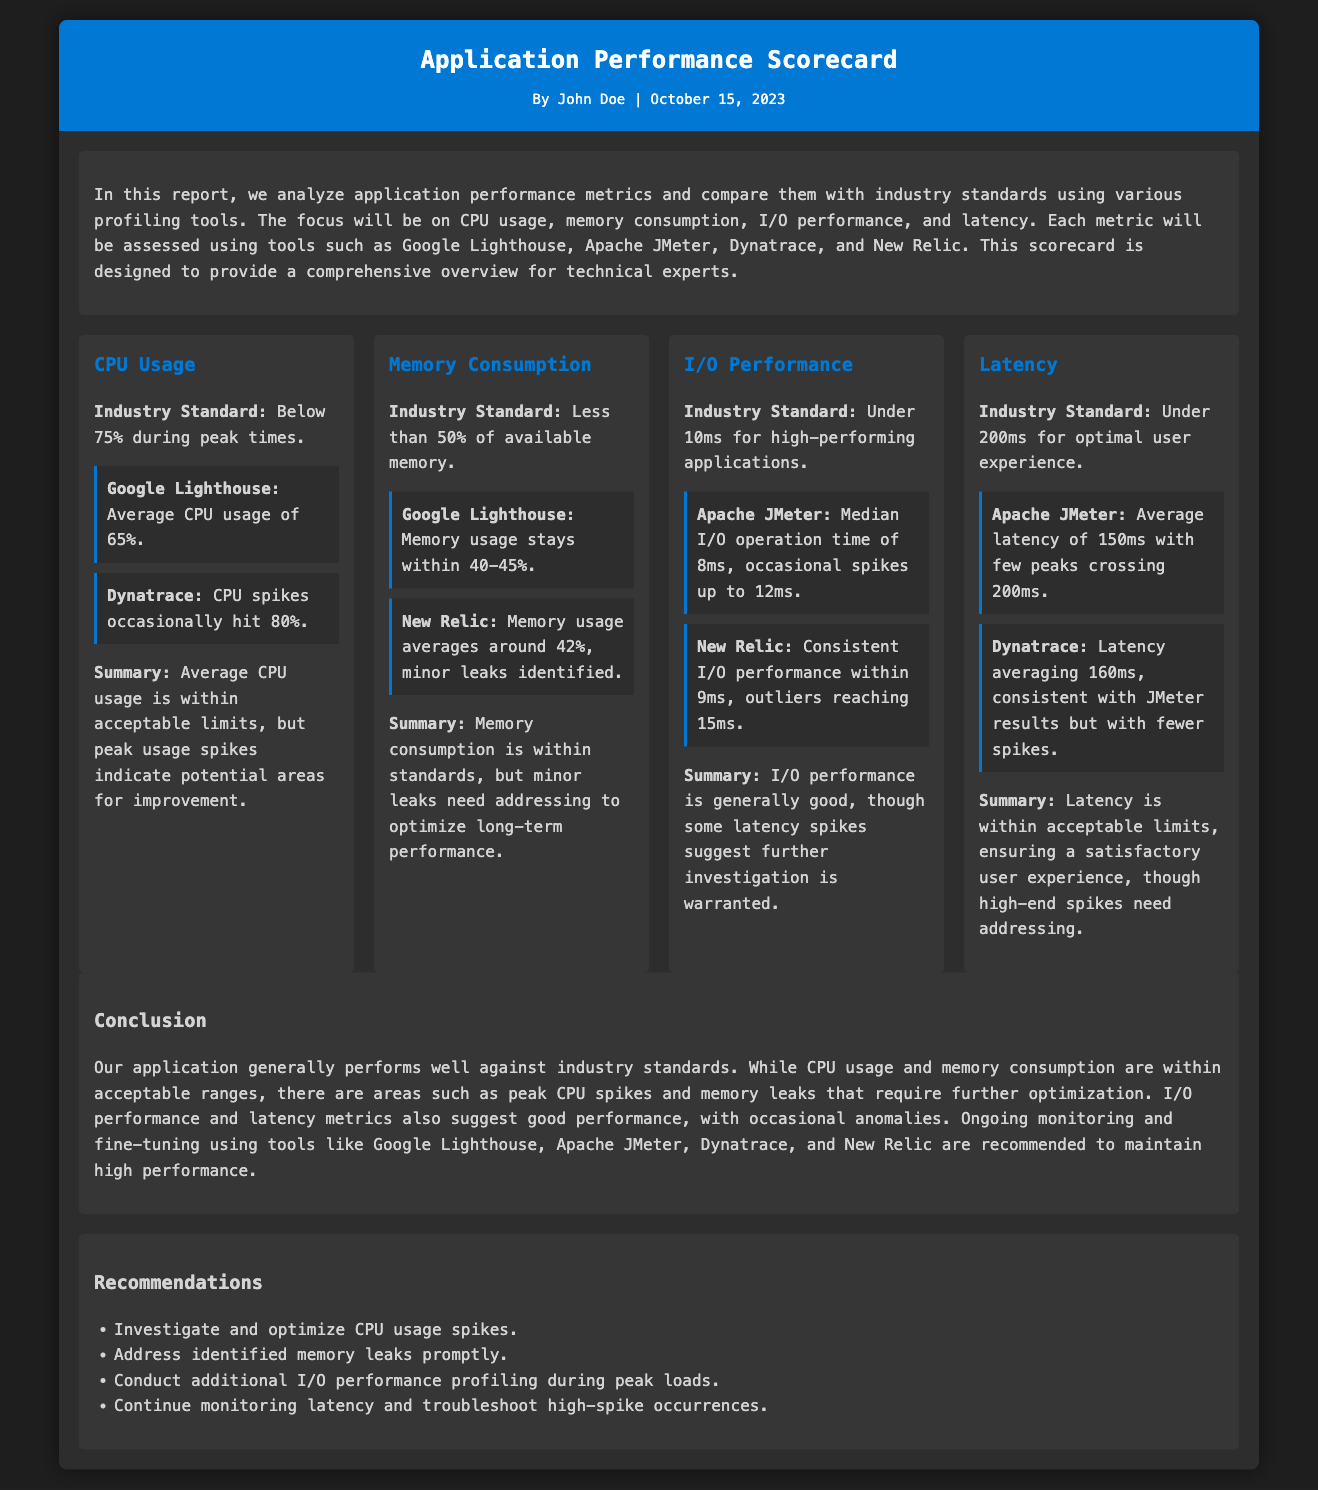what is the average CPU usage according to Google Lighthouse? The average CPU usage according to Google Lighthouse is mentioned as 65%.
Answer: 65% what is the industry standard for memory consumption? The industry standard for memory consumption is specified as less than 50% of available memory.
Answer: Less than 50% what was the median I/O operation time reported by Apache JMeter? The median I/O operation time reported by Apache JMeter is 8ms, with occasional spikes noted.
Answer: 8ms what is the average latency according to Dynatrace? The average latency according to Dynatrace is stated as 160ms.
Answer: 160ms how many recommendations are provided in the report? The report provides a list of four recommendations at the end.
Answer: Four which profiling tool identified memory leaks? The profiling tool that identified memory leaks is New Relic.
Answer: New Relic what is the peak CPU usage spike mentioned in the report? The peak CPU usage spike noted in the report occasionally hits 80%.
Answer: 80% what needs to be addressed regarding latency, according to the conclusion? The conclusion states that high-end spikes in latency need addressing.
Answer: High-end spikes 